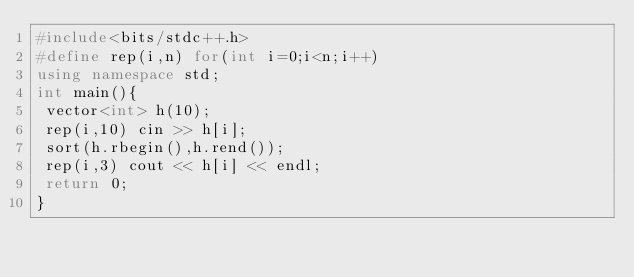Convert code to text. <code><loc_0><loc_0><loc_500><loc_500><_C++_>#include<bits/stdc++.h>
#define rep(i,n) for(int i=0;i<n;i++)
using namespace std;
int main(){
 vector<int> h(10);
 rep(i,10) cin >> h[i];
 sort(h.rbegin(),h.rend());
 rep(i,3) cout << h[i] << endl;
 return 0;
}
</code> 